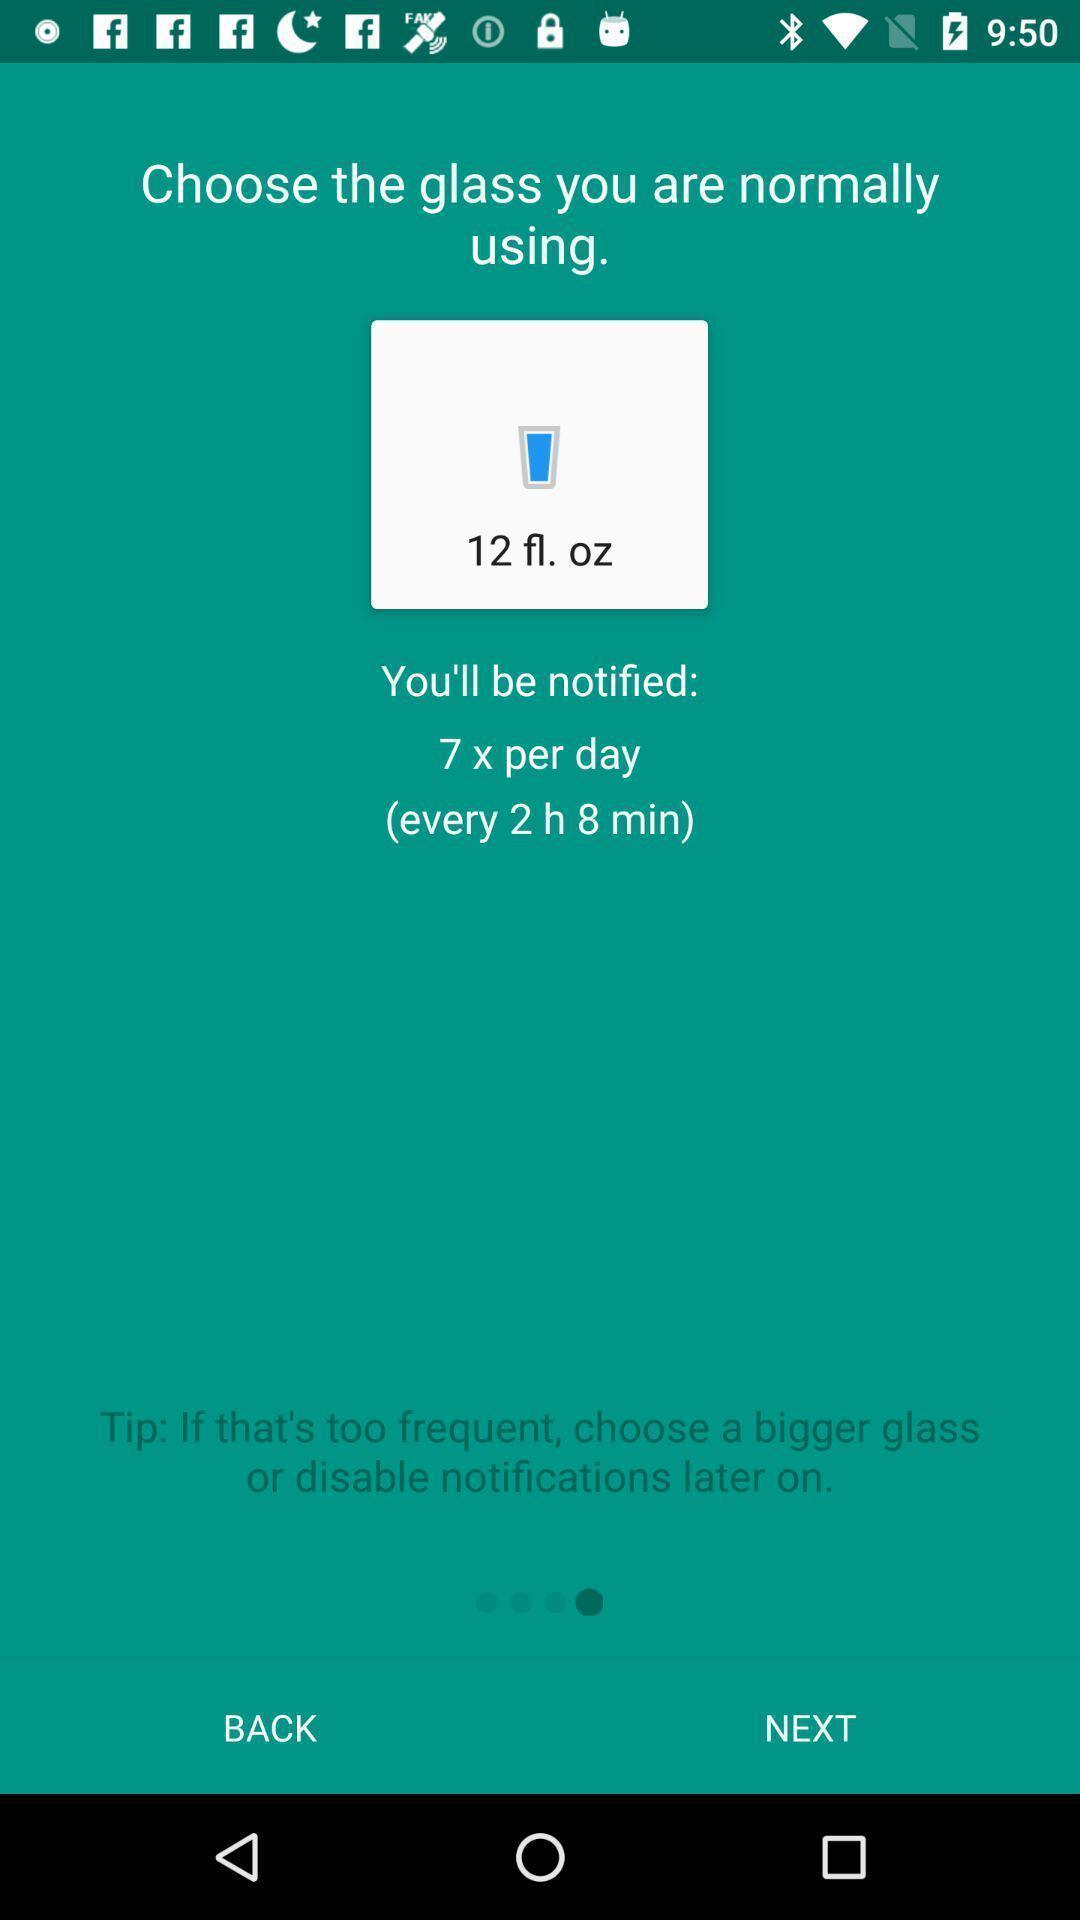Provide a detailed account of this screenshot. Page with instruction on how to use the app. 